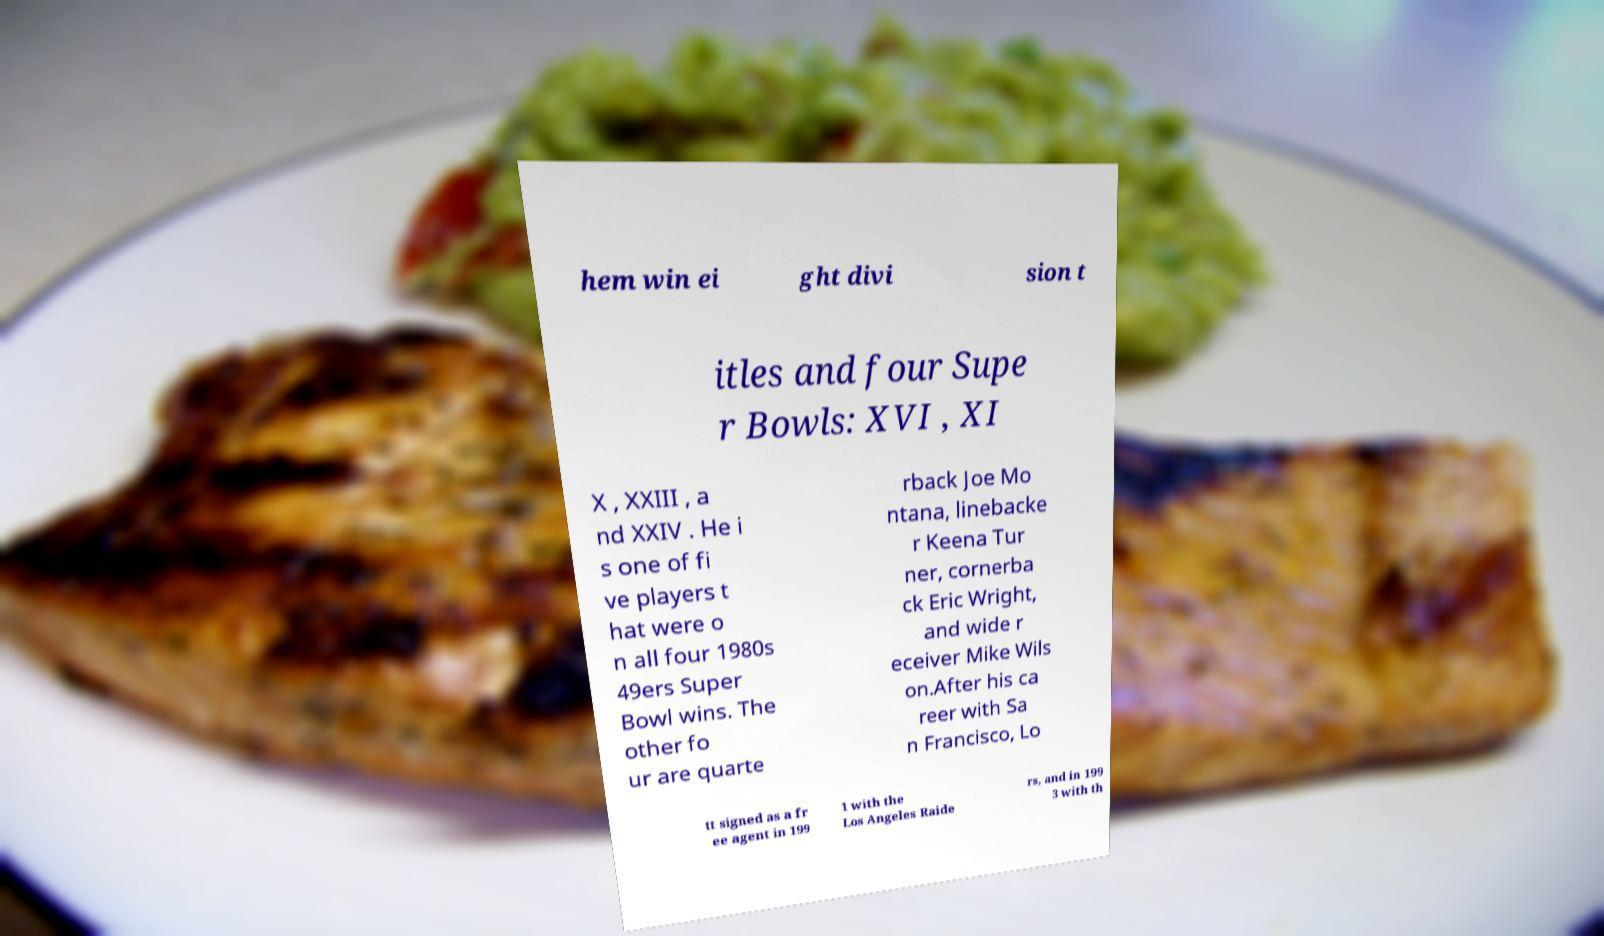Can you read and provide the text displayed in the image?This photo seems to have some interesting text. Can you extract and type it out for me? hem win ei ght divi sion t itles and four Supe r Bowls: XVI , XI X , XXIII , a nd XXIV . He i s one of fi ve players t hat were o n all four 1980s 49ers Super Bowl wins. The other fo ur are quarte rback Joe Mo ntana, linebacke r Keena Tur ner, cornerba ck Eric Wright, and wide r eceiver Mike Wils on.After his ca reer with Sa n Francisco, Lo tt signed as a fr ee agent in 199 1 with the Los Angeles Raide rs, and in 199 3 with th 